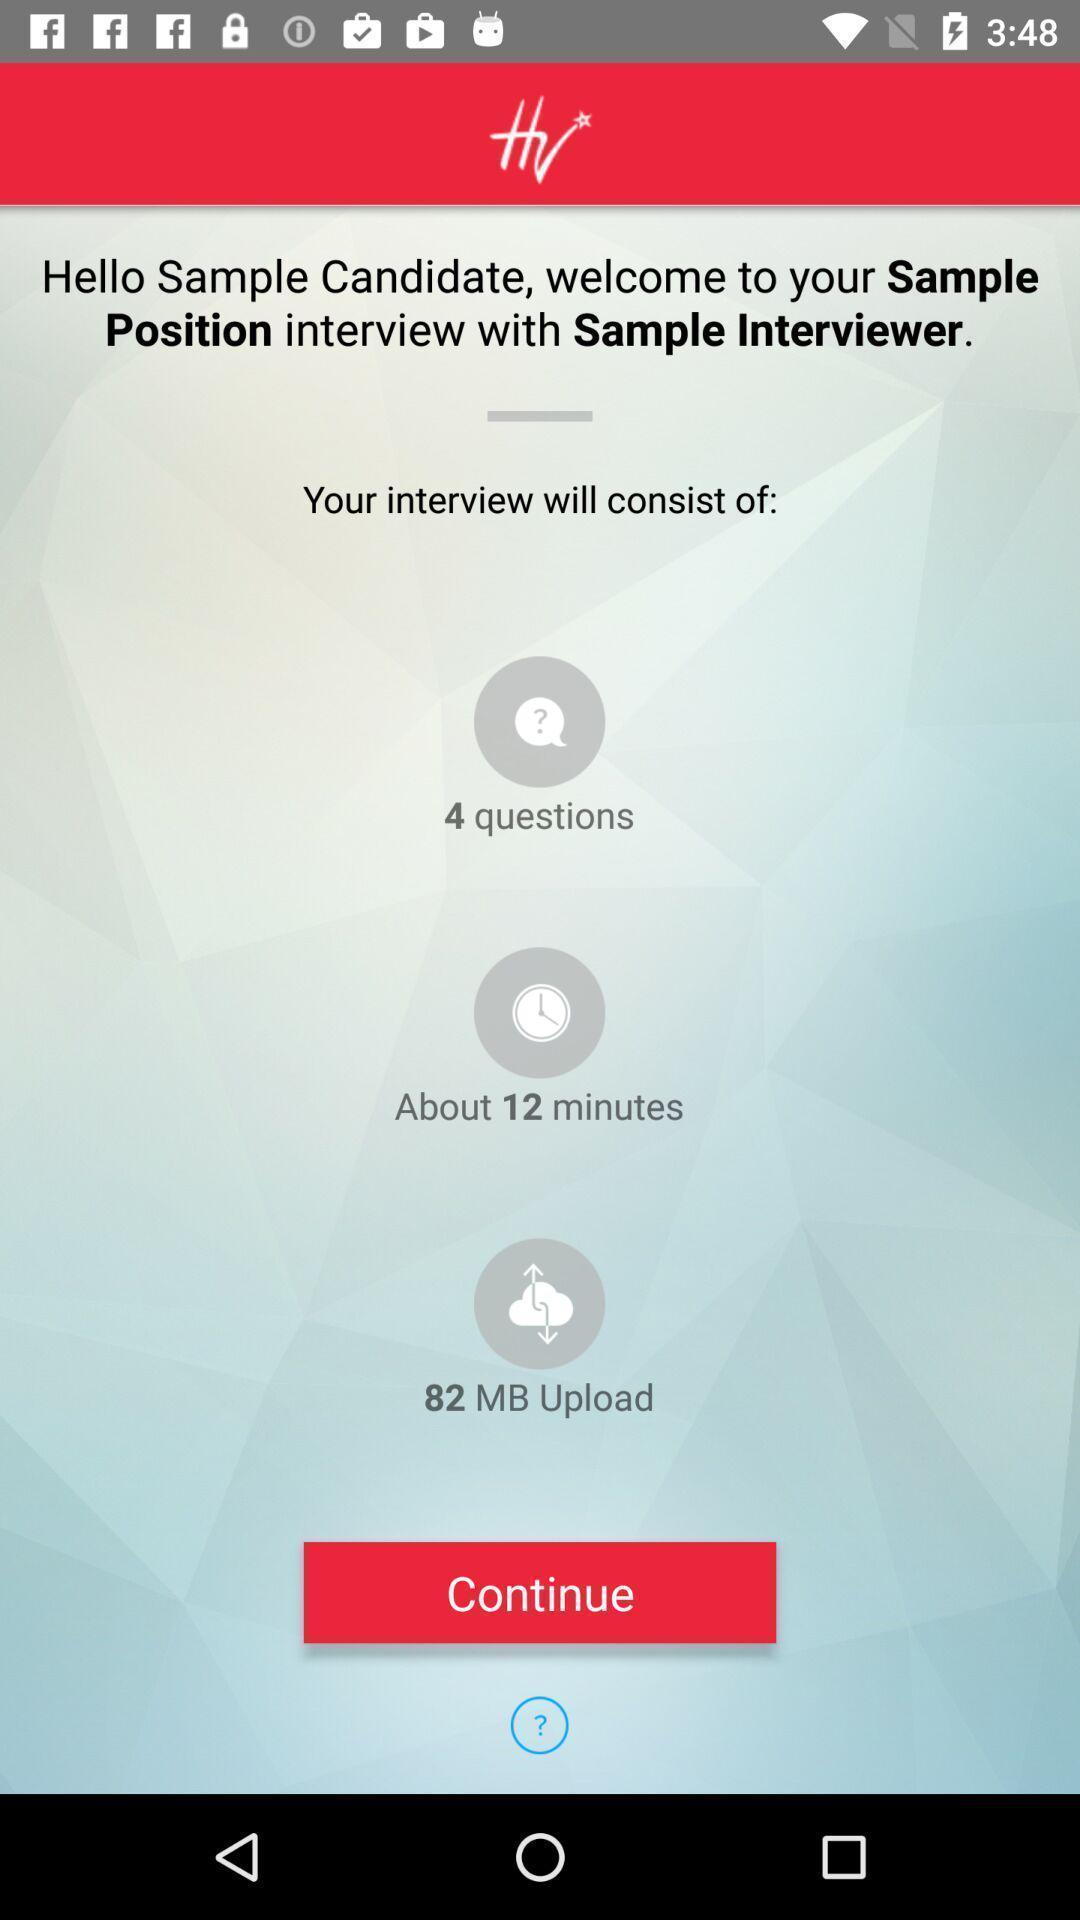Provide a detailed account of this screenshot. Screen displaying the page of an interview app. 